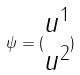Convert formula to latex. <formula><loc_0><loc_0><loc_500><loc_500>\psi = ( \begin{matrix} u ^ { 1 } \\ u ^ { 2 } \end{matrix} )</formula> 